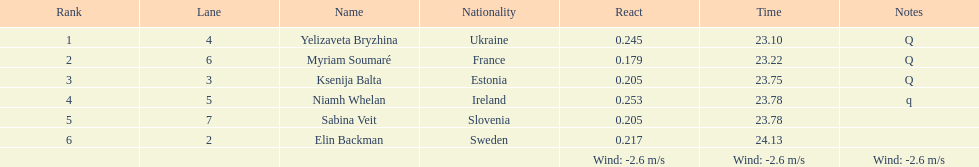In what amount of time did elin backman finish the race? 24.13. 